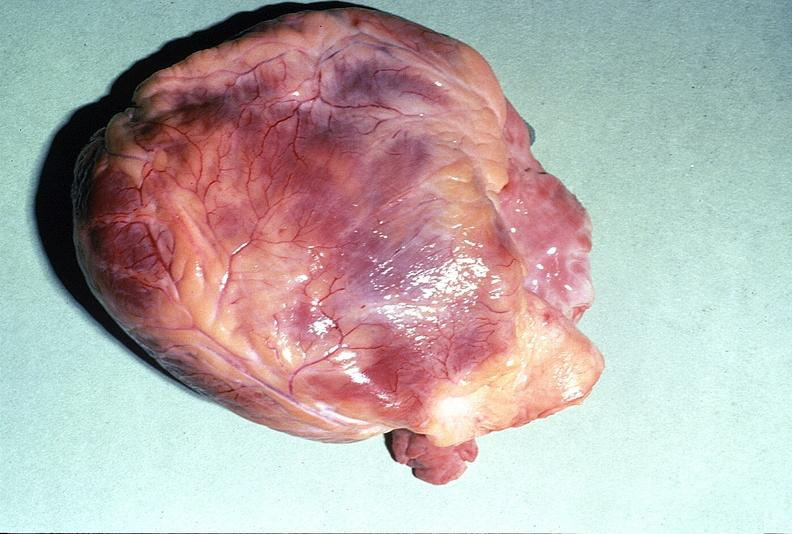where is this?
Answer the question using a single word or phrase. Heart 